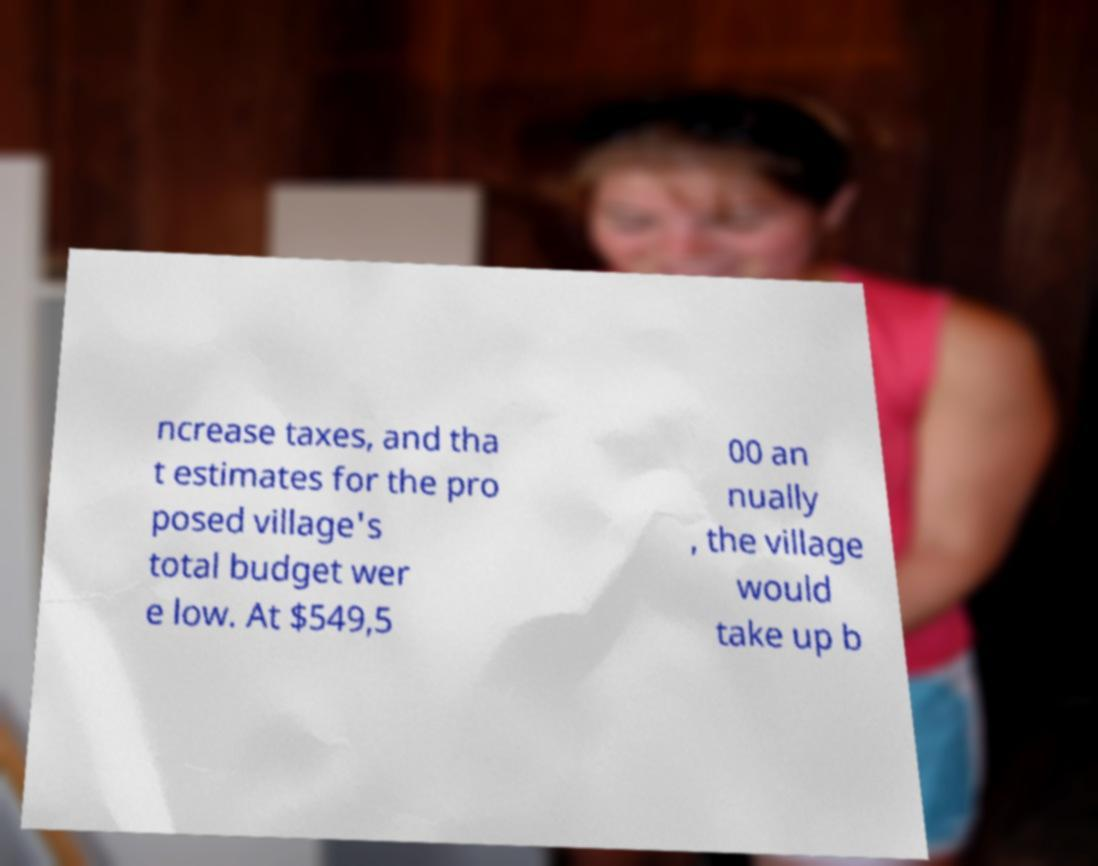Can you read and provide the text displayed in the image?This photo seems to have some interesting text. Can you extract and type it out for me? ncrease taxes, and tha t estimates for the pro posed village's total budget wer e low. At $549,5 00 an nually , the village would take up b 